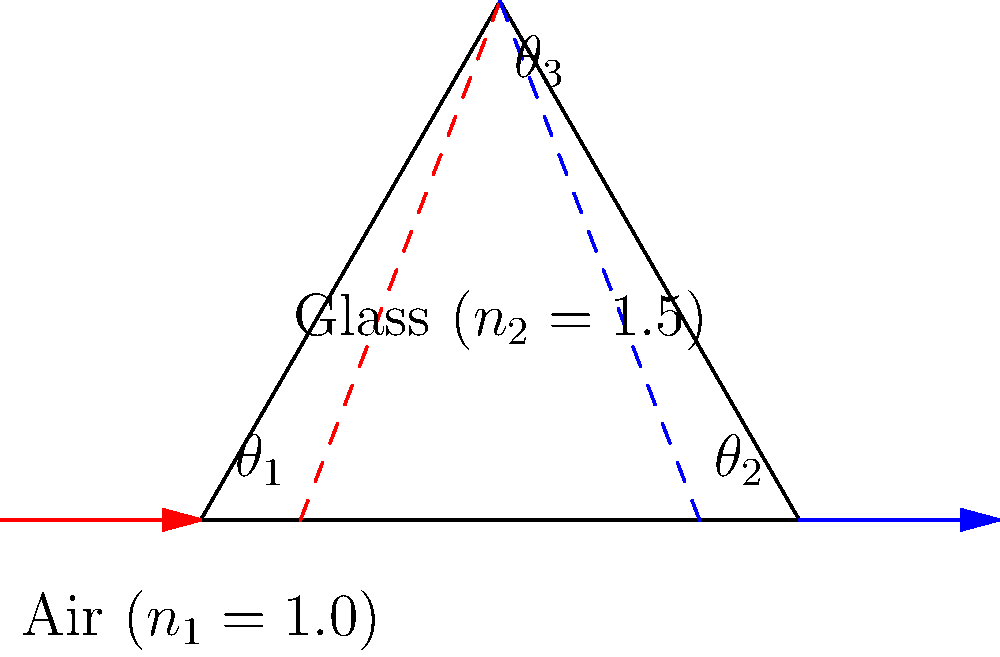As a junior executive climbing the corporate ladder, you're tasked with explaining a complex physics concept to a team of engineers. Consider a light ray passing through a glass prism as shown in the diagram. If the angle of incidence ($\theta_1$) is 30°, and the refractive index of glass ($n_2$) is 1.5, what is the angle of refraction ($\theta_2$) inside the prism? To solve this problem, we'll use Snell's law, which describes the relationship between the angles of incidence and refraction when light passes between two different media:

1) Snell's law: $n_1 \sin(\theta_1) = n_2 \sin(\theta_2)$

2) We know:
   - $n_1 = 1.0$ (air)
   - $n_2 = 1.5$ (glass)
   - $\theta_1 = 30°$

3) Substituting these values into Snell's law:
   $1.0 \sin(30°) = 1.5 \sin(\theta_2)$

4) Simplify:
   $0.5 = 1.5 \sin(\theta_2)$

5) Solve for $\theta_2$:
   $\sin(\theta_2) = \frac{0.5}{1.5} = \frac{1}{3}$

6) Take the inverse sine (arcsin) of both sides:
   $\theta_2 = \arcsin(\frac{1}{3})$

7) Calculate:
   $\theta_2 \approx 19.47°$

Therefore, the angle of refraction ($\theta_2$) inside the prism is approximately 19.47°.
Answer: $19.47°$ 